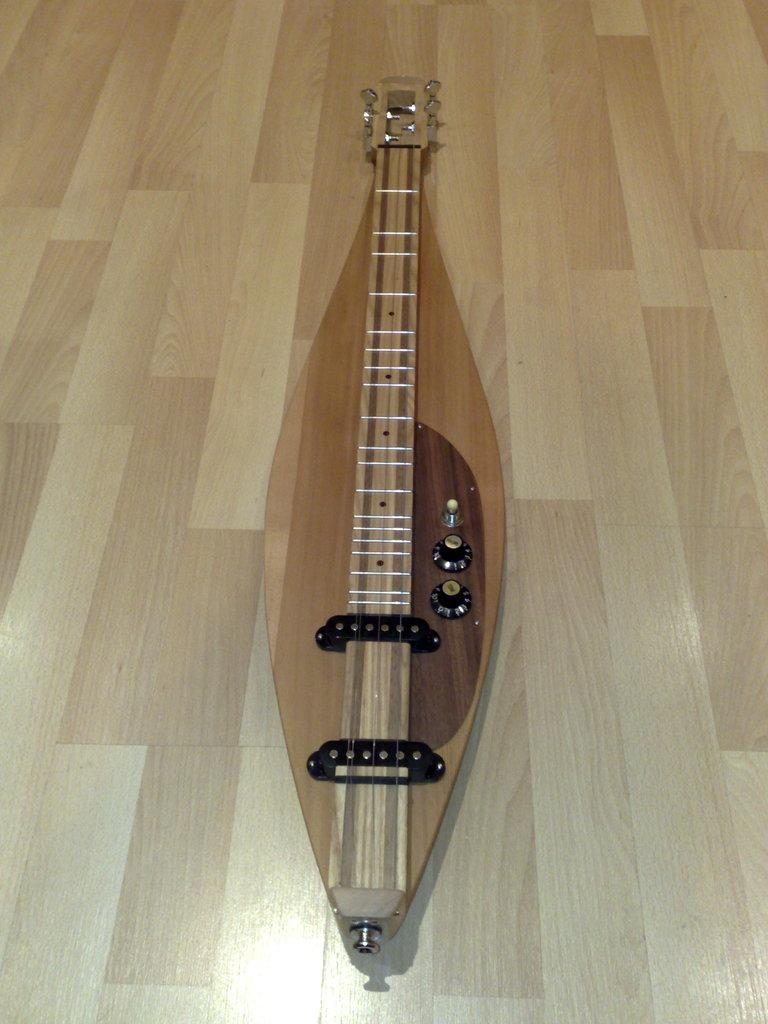What object in the image can be used to create music? There is a musical instrument in the image that can be used to create music. Where is the musical instrument located in the image? The musical instrument is placed on the floor. How does the musical instrument produce sound? The musical instrument has strings to play music with it. What type of needle is used to play the musical instrument in the image? There is no needle involved in playing the musical instrument in the image; it is played by plucking or strumming the strings. 